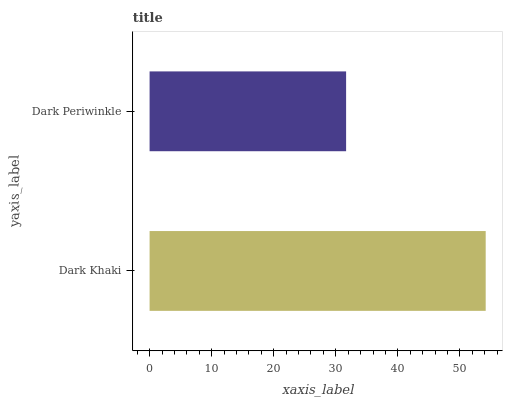Is Dark Periwinkle the minimum?
Answer yes or no. Yes. Is Dark Khaki the maximum?
Answer yes or no. Yes. Is Dark Periwinkle the maximum?
Answer yes or no. No. Is Dark Khaki greater than Dark Periwinkle?
Answer yes or no. Yes. Is Dark Periwinkle less than Dark Khaki?
Answer yes or no. Yes. Is Dark Periwinkle greater than Dark Khaki?
Answer yes or no. No. Is Dark Khaki less than Dark Periwinkle?
Answer yes or no. No. Is Dark Khaki the high median?
Answer yes or no. Yes. Is Dark Periwinkle the low median?
Answer yes or no. Yes. Is Dark Periwinkle the high median?
Answer yes or no. No. Is Dark Khaki the low median?
Answer yes or no. No. 